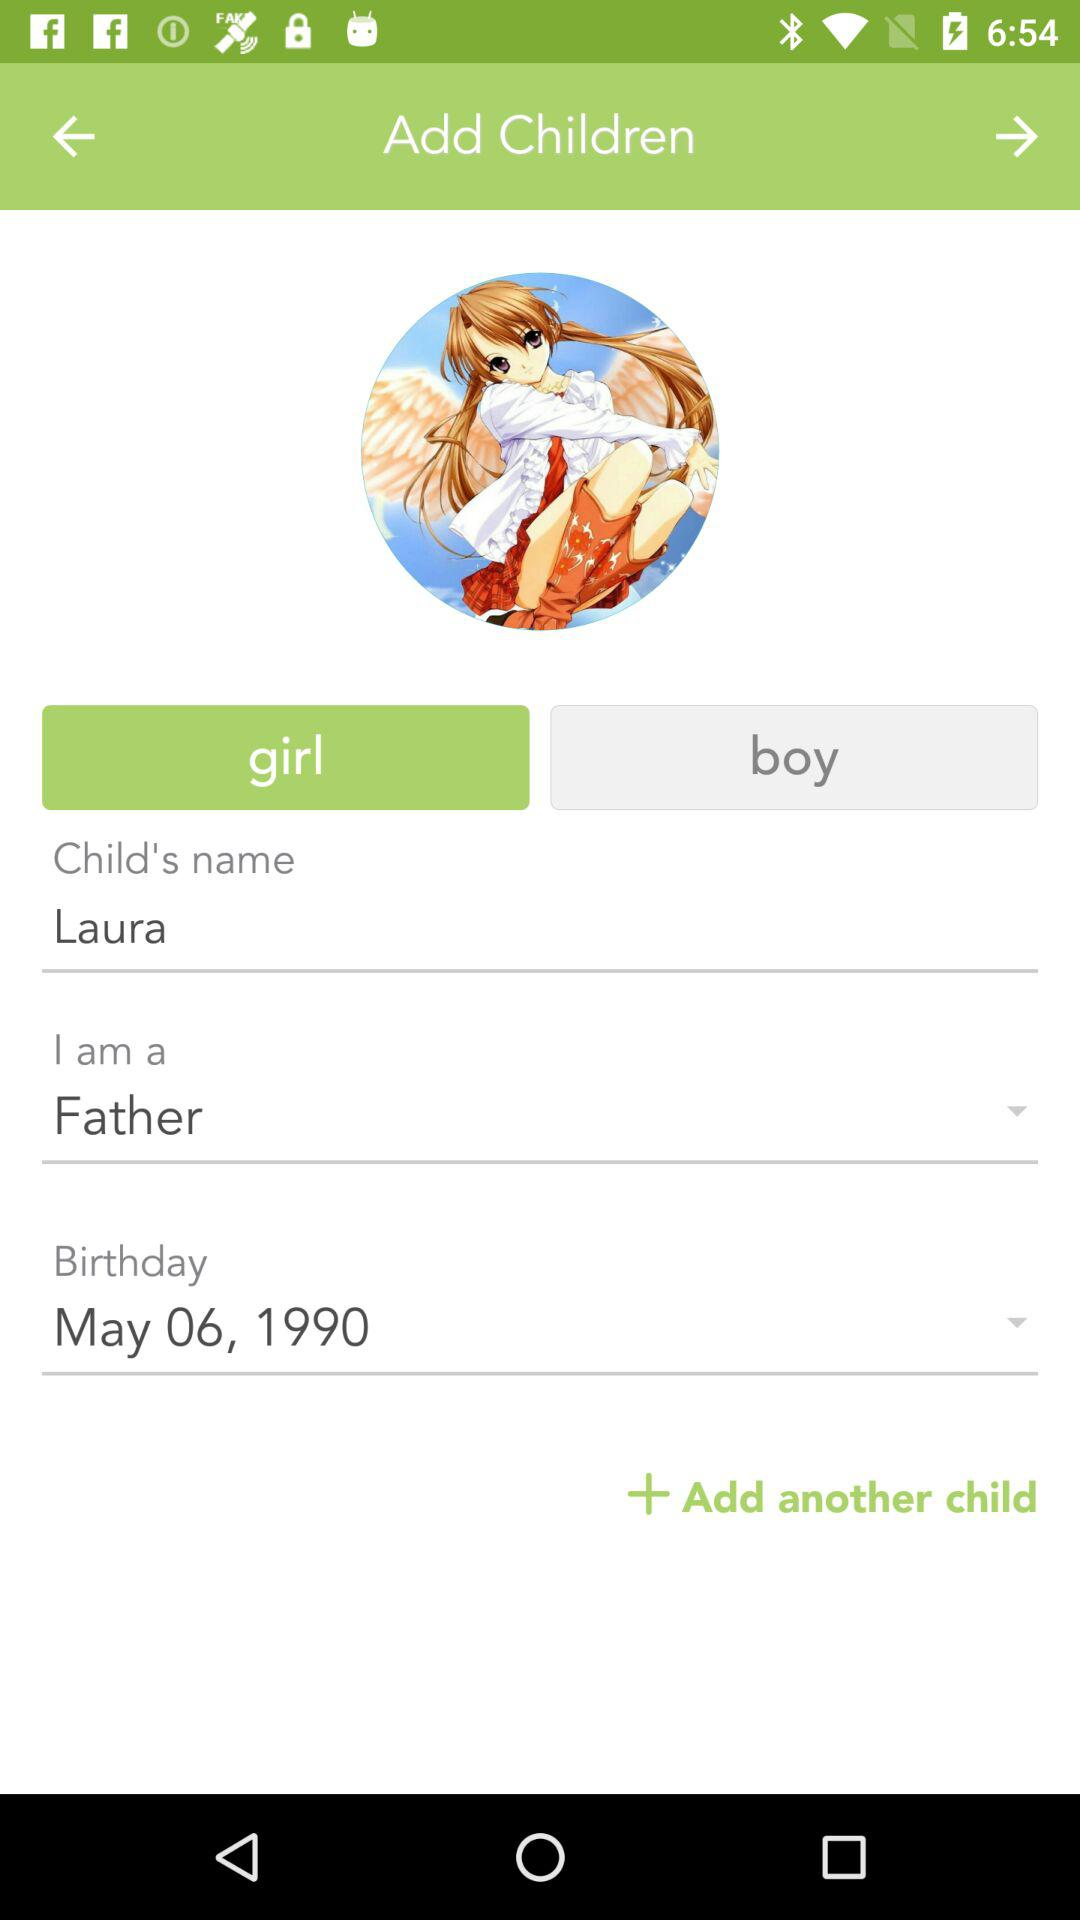What is the user's relationship with the child? The user is the father of the child. 